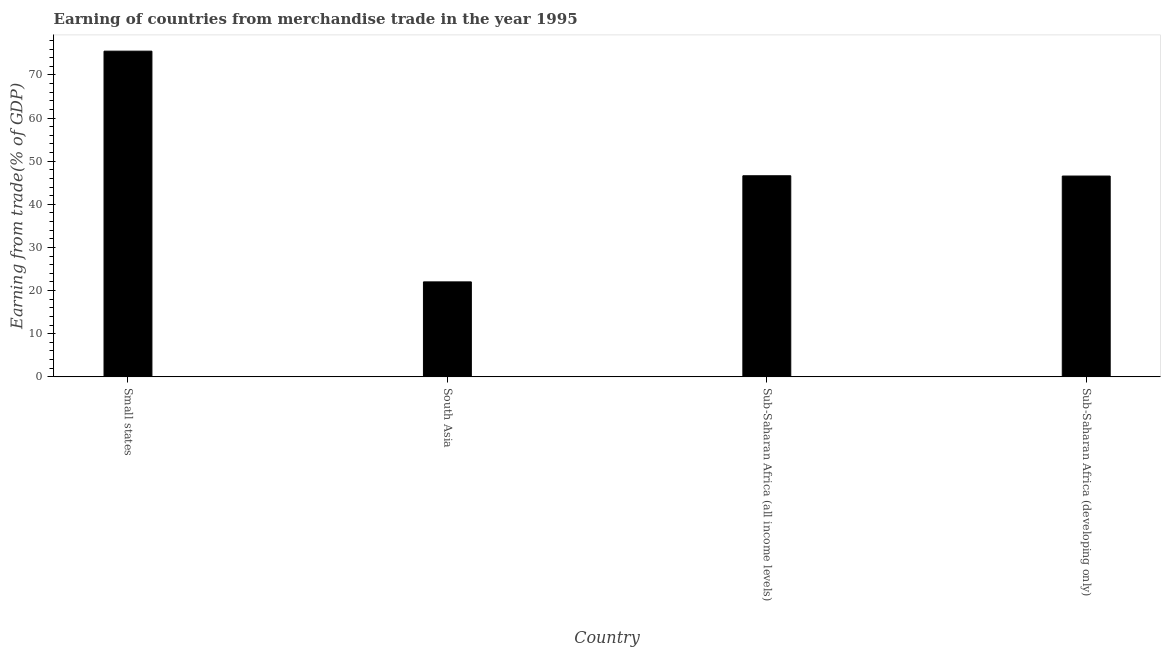What is the title of the graph?
Make the answer very short. Earning of countries from merchandise trade in the year 1995. What is the label or title of the X-axis?
Your answer should be compact. Country. What is the label or title of the Y-axis?
Offer a very short reply. Earning from trade(% of GDP). What is the earning from merchandise trade in Small states?
Keep it short and to the point. 75.5. Across all countries, what is the maximum earning from merchandise trade?
Give a very brief answer. 75.5. Across all countries, what is the minimum earning from merchandise trade?
Offer a very short reply. 22.02. In which country was the earning from merchandise trade maximum?
Ensure brevity in your answer.  Small states. What is the sum of the earning from merchandise trade?
Keep it short and to the point. 190.69. What is the difference between the earning from merchandise trade in South Asia and Sub-Saharan Africa (developing only)?
Your answer should be very brief. -24.53. What is the average earning from merchandise trade per country?
Provide a short and direct response. 47.67. What is the median earning from merchandise trade?
Give a very brief answer. 46.59. In how many countries, is the earning from merchandise trade greater than 42 %?
Keep it short and to the point. 3. What is the ratio of the earning from merchandise trade in Small states to that in Sub-Saharan Africa (developing only)?
Your response must be concise. 1.62. What is the difference between the highest and the second highest earning from merchandise trade?
Make the answer very short. 28.88. Is the sum of the earning from merchandise trade in South Asia and Sub-Saharan Africa (all income levels) greater than the maximum earning from merchandise trade across all countries?
Offer a terse response. No. What is the difference between the highest and the lowest earning from merchandise trade?
Offer a very short reply. 53.48. In how many countries, is the earning from merchandise trade greater than the average earning from merchandise trade taken over all countries?
Offer a terse response. 1. How many bars are there?
Give a very brief answer. 4. Are all the bars in the graph horizontal?
Your answer should be compact. No. Are the values on the major ticks of Y-axis written in scientific E-notation?
Keep it short and to the point. No. What is the Earning from trade(% of GDP) in Small states?
Your answer should be compact. 75.5. What is the Earning from trade(% of GDP) in South Asia?
Give a very brief answer. 22.02. What is the Earning from trade(% of GDP) of Sub-Saharan Africa (all income levels)?
Make the answer very short. 46.62. What is the Earning from trade(% of GDP) of Sub-Saharan Africa (developing only)?
Offer a very short reply. 46.55. What is the difference between the Earning from trade(% of GDP) in Small states and South Asia?
Ensure brevity in your answer.  53.48. What is the difference between the Earning from trade(% of GDP) in Small states and Sub-Saharan Africa (all income levels)?
Provide a short and direct response. 28.88. What is the difference between the Earning from trade(% of GDP) in Small states and Sub-Saharan Africa (developing only)?
Keep it short and to the point. 28.95. What is the difference between the Earning from trade(% of GDP) in South Asia and Sub-Saharan Africa (all income levels)?
Your response must be concise. -24.6. What is the difference between the Earning from trade(% of GDP) in South Asia and Sub-Saharan Africa (developing only)?
Your answer should be very brief. -24.53. What is the difference between the Earning from trade(% of GDP) in Sub-Saharan Africa (all income levels) and Sub-Saharan Africa (developing only)?
Keep it short and to the point. 0.07. What is the ratio of the Earning from trade(% of GDP) in Small states to that in South Asia?
Provide a short and direct response. 3.43. What is the ratio of the Earning from trade(% of GDP) in Small states to that in Sub-Saharan Africa (all income levels)?
Your answer should be very brief. 1.62. What is the ratio of the Earning from trade(% of GDP) in Small states to that in Sub-Saharan Africa (developing only)?
Make the answer very short. 1.62. What is the ratio of the Earning from trade(% of GDP) in South Asia to that in Sub-Saharan Africa (all income levels)?
Offer a terse response. 0.47. What is the ratio of the Earning from trade(% of GDP) in South Asia to that in Sub-Saharan Africa (developing only)?
Your answer should be compact. 0.47. What is the ratio of the Earning from trade(% of GDP) in Sub-Saharan Africa (all income levels) to that in Sub-Saharan Africa (developing only)?
Make the answer very short. 1. 